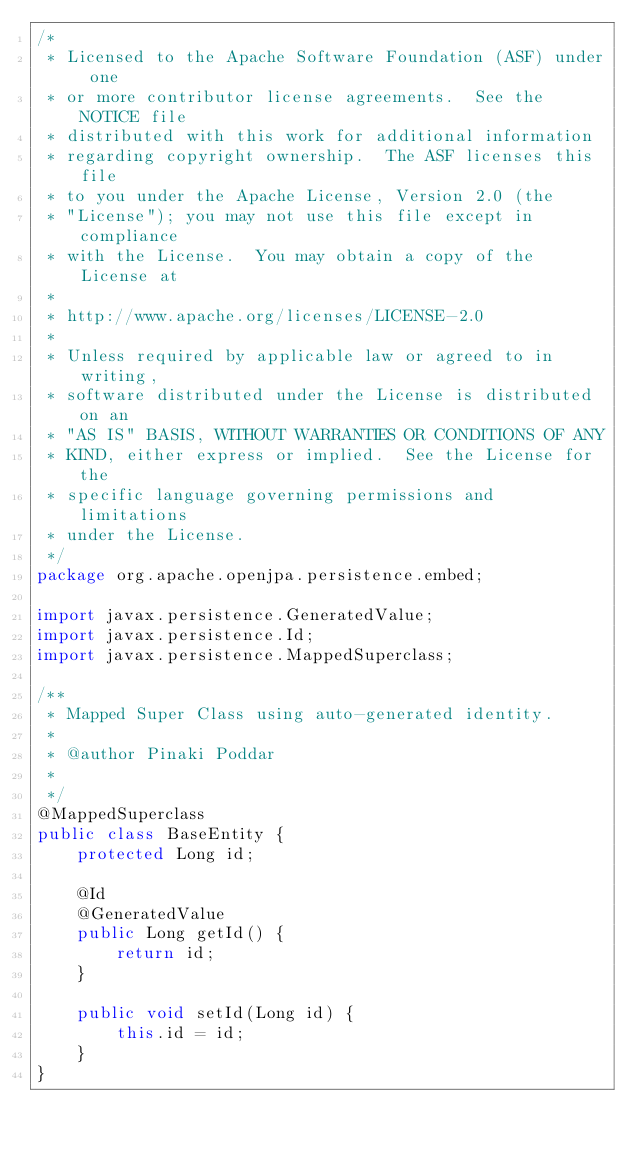<code> <loc_0><loc_0><loc_500><loc_500><_Java_>/*
 * Licensed to the Apache Software Foundation (ASF) under one
 * or more contributor license agreements.  See the NOTICE file
 * distributed with this work for additional information
 * regarding copyright ownership.  The ASF licenses this file
 * to you under the Apache License, Version 2.0 (the
 * "License"); you may not use this file except in compliance
 * with the License.  You may obtain a copy of the License at
 *
 * http://www.apache.org/licenses/LICENSE-2.0
 *
 * Unless required by applicable law or agreed to in writing,
 * software distributed under the License is distributed on an
 * "AS IS" BASIS, WITHOUT WARRANTIES OR CONDITIONS OF ANY
 * KIND, either express or implied.  See the License for the
 * specific language governing permissions and limitations
 * under the License.
 */
package org.apache.openjpa.persistence.embed;

import javax.persistence.GeneratedValue;
import javax.persistence.Id;
import javax.persistence.MappedSuperclass;

/**
 * Mapped Super Class using auto-generated identity.
 *
 * @author Pinaki Poddar
 *
 */
@MappedSuperclass
public class BaseEntity {
    protected Long id;

    @Id
    @GeneratedValue
    public Long getId() {
        return id;
    }

    public void setId(Long id) {
        this.id = id;
    }
}
</code> 